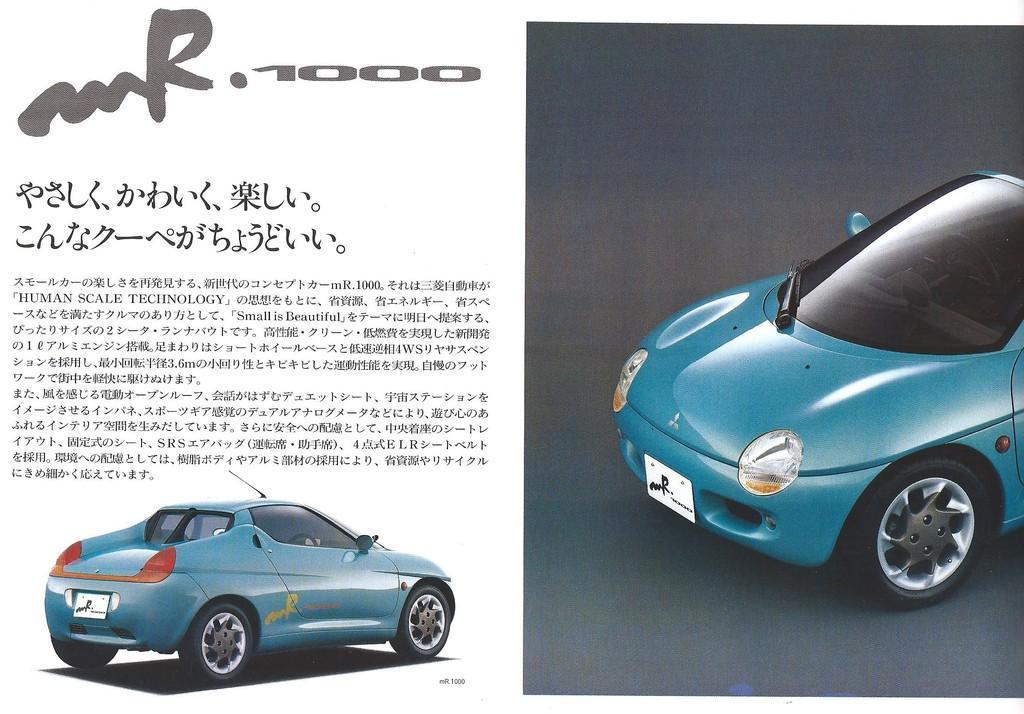How would you summarize this image in a sentence or two? On the left side the image we can see some edited text here and a car which is in blue color. On the right side of the image we can see the front view of the car which is in the black background. 